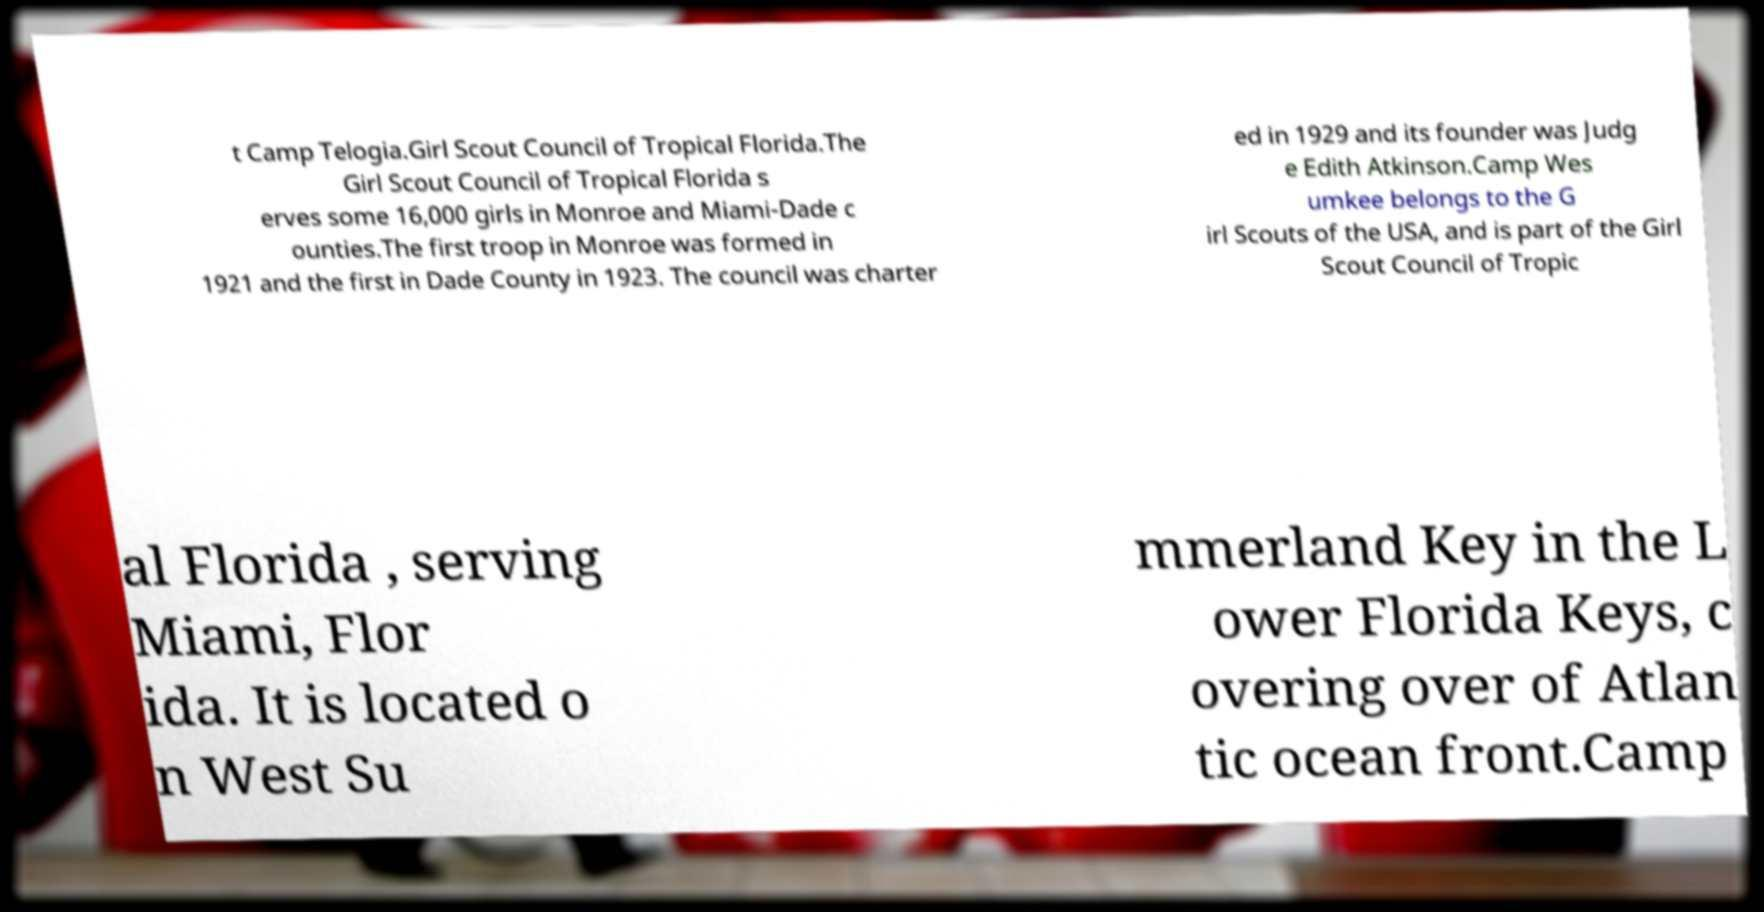Please read and relay the text visible in this image. What does it say? t Camp Telogia.Girl Scout Council of Tropical Florida.The Girl Scout Council of Tropical Florida s erves some 16,000 girls in Monroe and Miami-Dade c ounties.The first troop in Monroe was formed in 1921 and the first in Dade County in 1923. The council was charter ed in 1929 and its founder was Judg e Edith Atkinson.Camp Wes umkee belongs to the G irl Scouts of the USA, and is part of the Girl Scout Council of Tropic al Florida , serving Miami, Flor ida. It is located o n West Su mmerland Key in the L ower Florida Keys, c overing over of Atlan tic ocean front.Camp 